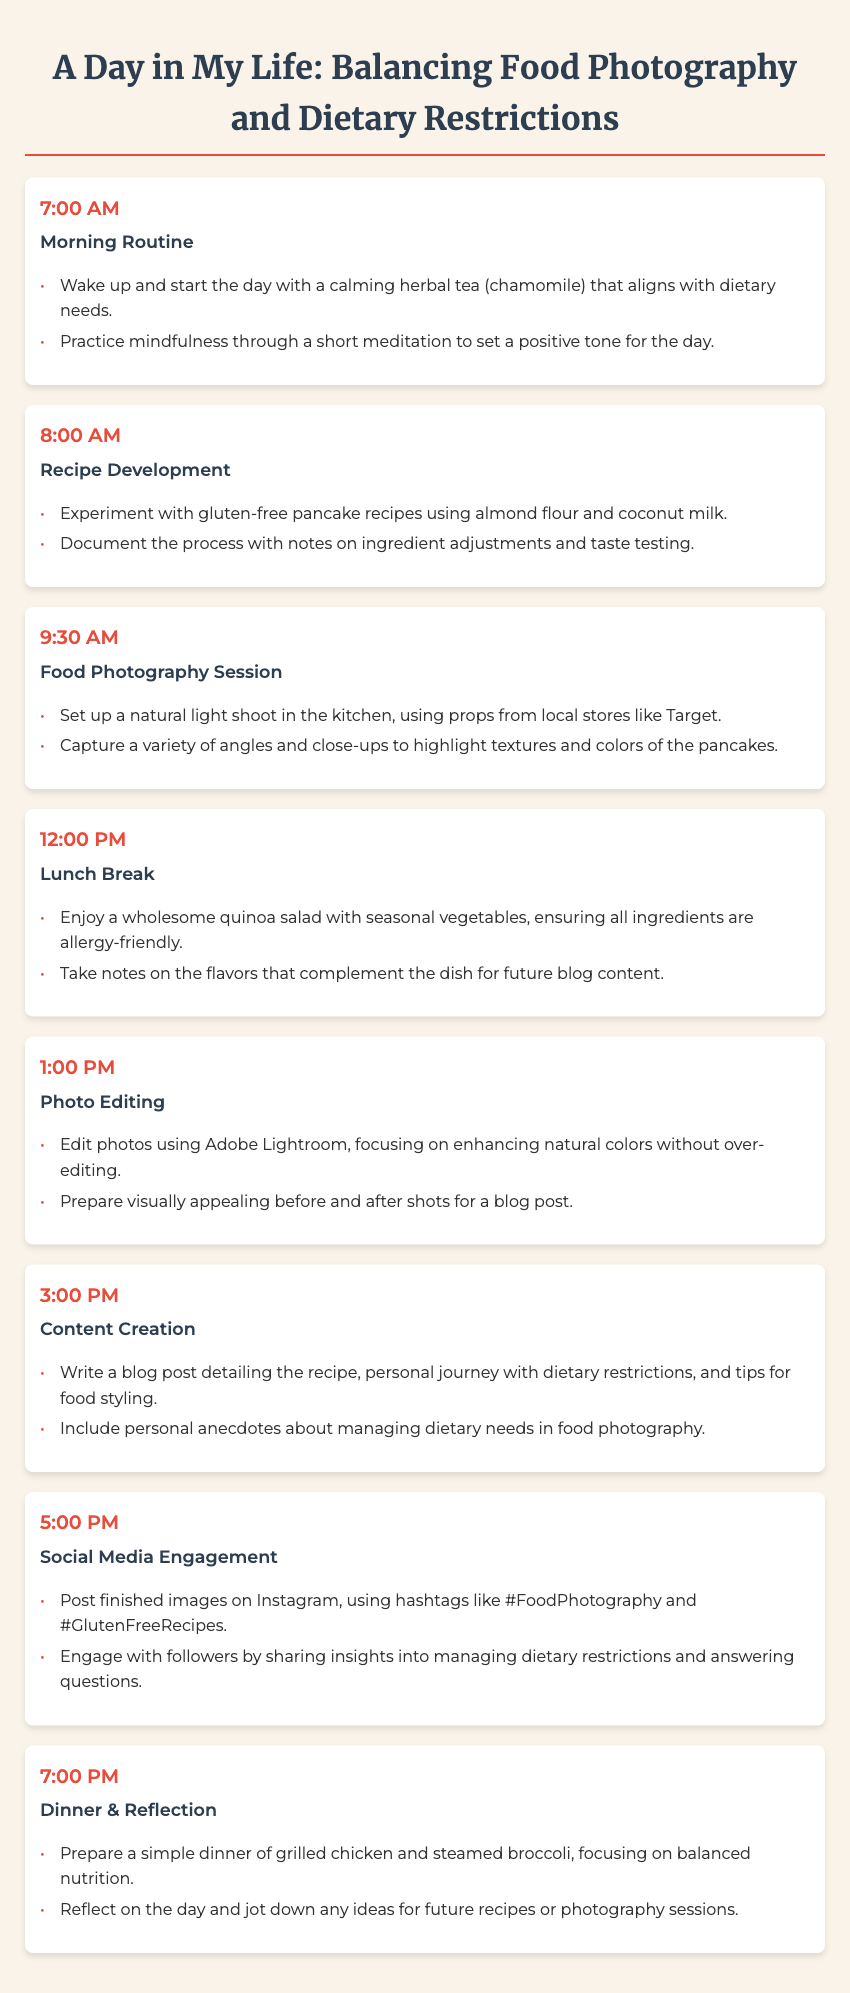What time does the morning routine start? The morning routine starts at 7:00 AM as indicated in the agenda.
Answer: 7:00 AM What meal is featured for lunch? The agenda specifies a wholesome quinoa salad with seasonal vegetables for lunch.
Answer: Quinoa salad What photography editing software is mentioned? The agenda mentions using Adobe Lightroom for photo editing.
Answer: Adobe Lightroom How many activities are listed in the agenda? There are a total of 7 activities listed from morning to evening in the agenda.
Answer: 7 What is a key focus during photo editing? The main focus during photo editing is enhancing natural colors without over-editing.
Answer: Natural colors What time is the dinner scheduled for? Dinner is scheduled for 7:00 PM according to the agenda.
Answer: 7:00 PM What type of recipes does the food photographer develop? The food photographer develops gluten-free pancake recipes as mentioned in the agenda.
Answer: Gluten-free pancake recipes What is a common theme in the content created? The common theme in the content is managing dietary restrictions while sharing recipes and tips.
Answer: Managing dietary restrictions What social media platform does the photographer engage with followers on? The photographer engages with followers on Instagram as noted in the agenda.
Answer: Instagram 